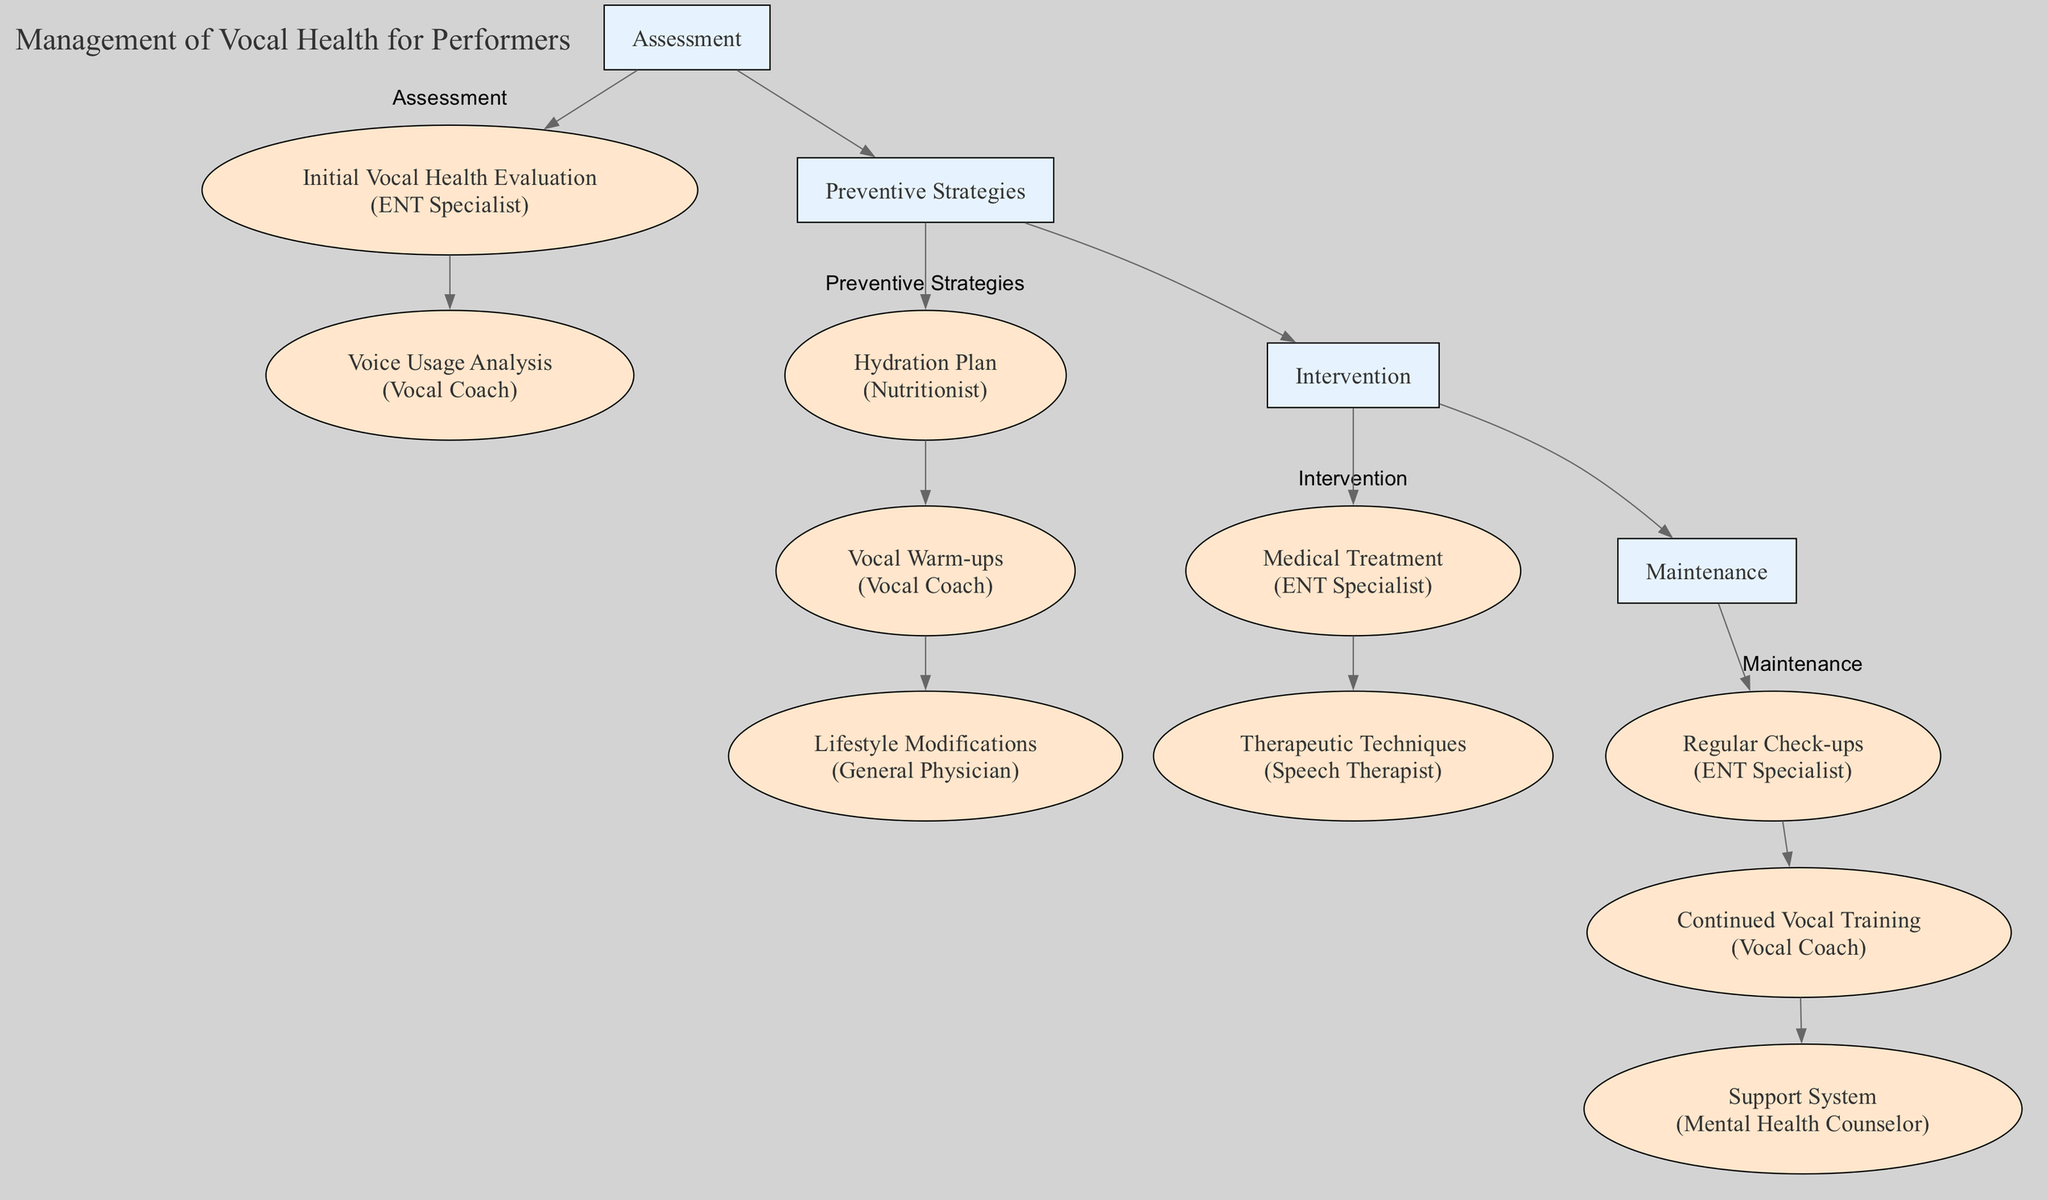What is the title of this clinical pathway? The title of the clinical pathway is found in the "Introduction" section. It is explicitly stated as "Management of Vocal Health for Performers."
Answer: Management of Vocal Health for Performers How many phases are in the clinical pathway? The clinical pathway contains a list of "Phases." By counting those listed, there are four distinct phases: Assessment, Preventive Strategies, Intervention, and Maintenance.
Answer: 4 Which entity is responsible for the Initial Vocal Health Evaluation? The step "Initial Vocal Health Evaluation" specifies that it is conducted by the "ENT Specialist." This can be identified as part of the Assessment phase in the diagram.
Answer: ENT Specialist What is the main purpose of the Hydration Plan? The "Hydration Plan" is described as a routine to ensure adequate hydration for maintaining vocal cord lubrication, indicated in the Preventive Strategies phase.
Answer: Maintain vocal cord lubrication How many steps are there in the Maintenance phase? It is necessary to inspect the Maintenance phase and count each of its components. There are three steps: Regular Check-ups, Continued Vocal Training, and Support System.
Answer: 3 Which two entities are involved in the Intervention phase? In the Intervention phase, there are two steps listed: "Medical Treatment" by the ENT Specialist and "Therapeutic Techniques" by the Speech Therapist. This requires referring to multiple entries in the diagram.
Answer: ENT Specialist and Speech Therapist What step follows Voice Usage Analysis in the Assessment phase? Following "Voice Usage Analysis," which is the second step of the Assessment phase, the diagram shows that no other step follows it in that specific phase. Thus, the next step is in the Preventive Strategies phase. The relationship can be observed as a sequential flow of phases rather than individual steps.
Answer: Hydration Plan What type of support does the Support System step provide? The "Support System" step within the Maintenance phase specifically refers to "Emotional and psychological support," emphasizing its role in coping with the pressures of performing.
Answer: Emotional and psychological support Which phase includes Lifestyle Modifications? The "Lifestyle Modifications" step is included in the Preventive Strategies phase of the clinical pathway. This can be confirmed by locating the step within the phase listed in the diagram.
Answer: Preventive Strategies 